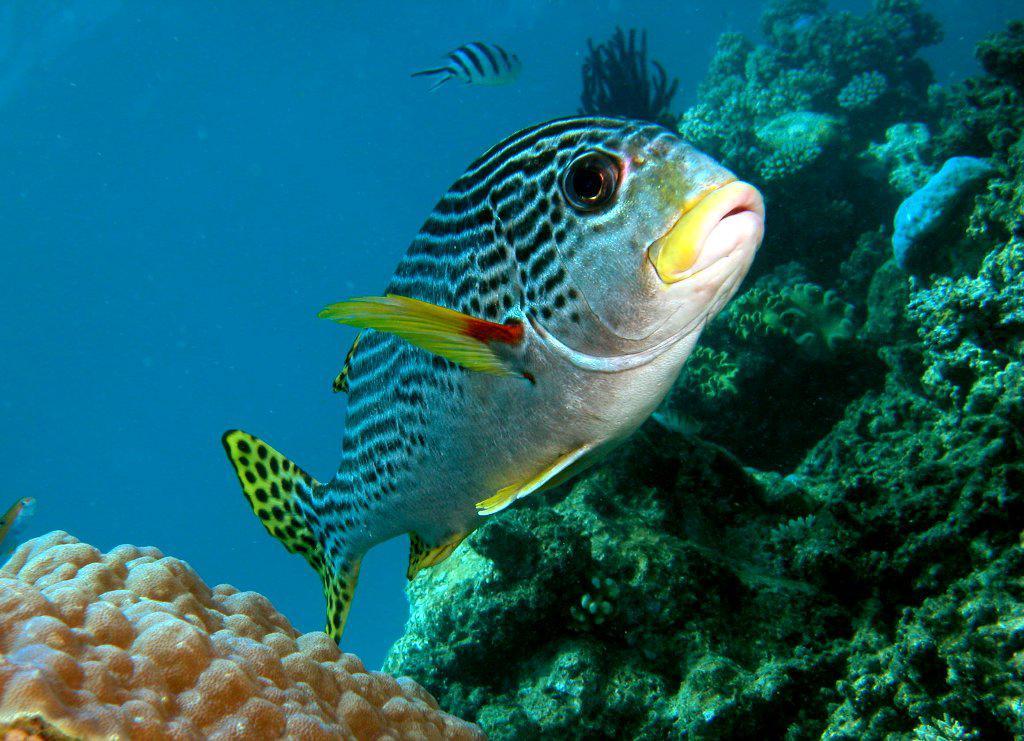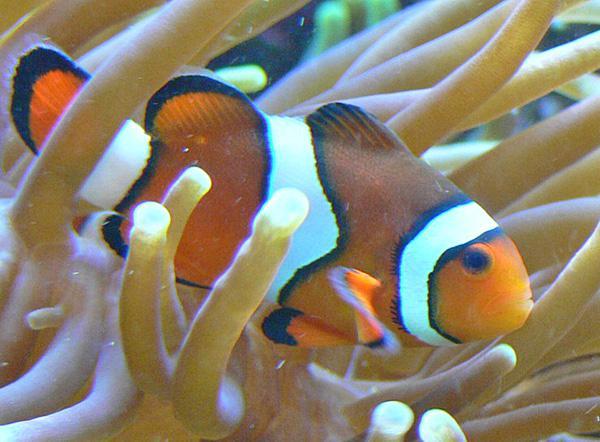The first image is the image on the left, the second image is the image on the right. Considering the images on both sides, is "There is a single clownfish swimming by the reef." valid? Answer yes or no. Yes. 